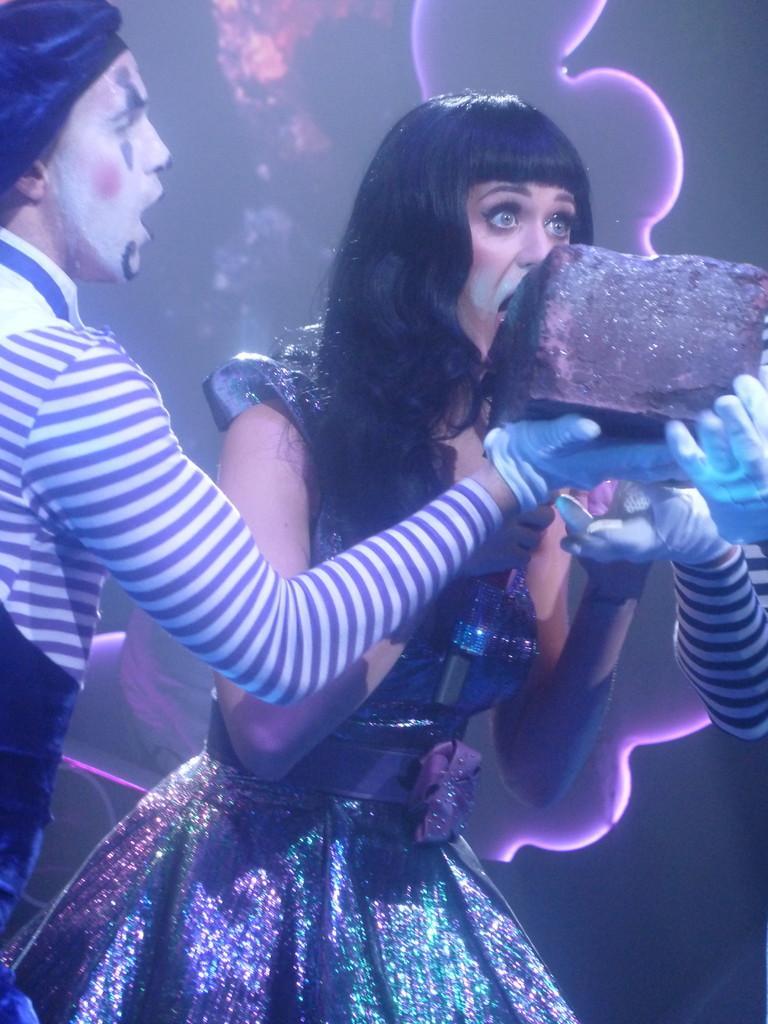In one or two sentences, can you explain what this image depicts? On the left side, there is a person in a T-shirt, holding a cake and speaking. In the middle of this image, there is a eating this cake. On the right side, there is a person, holding this cake. In the background, there is a screen. And the background is dark in color. 